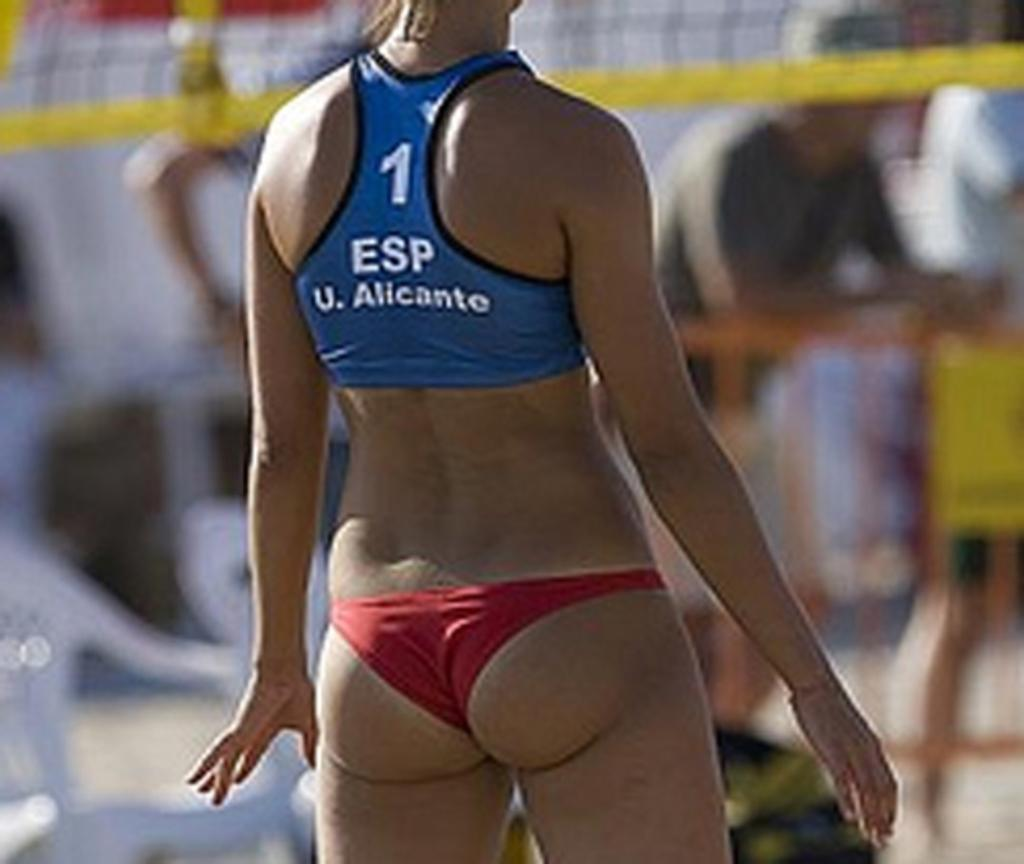<image>
Render a clear and concise summary of the photo. A woman with 1 Esp U. Alicante on the back of her uniform stands in front of a volleyball net. 